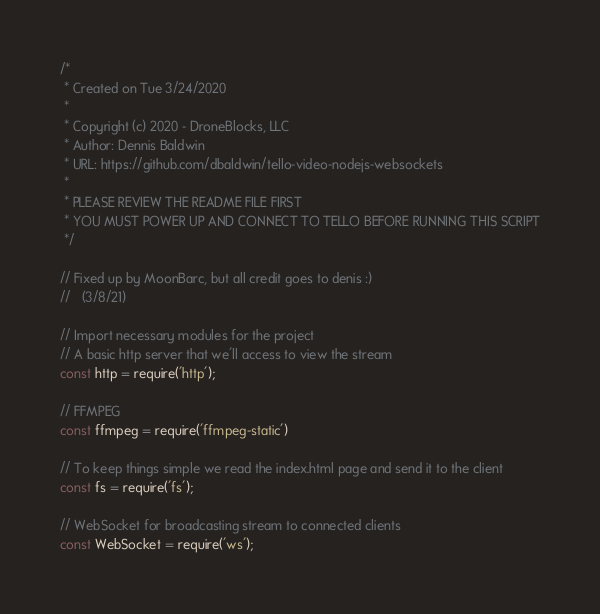<code> <loc_0><loc_0><loc_500><loc_500><_JavaScript_>/*
 * Created on Tue 3/24/2020
 *
 * Copyright (c) 2020 - DroneBlocks, LLC
 * Author: Dennis Baldwin
 * URL: https://github.com/dbaldwin/tello-video-nodejs-websockets
 *
 * PLEASE REVIEW THE README FILE FIRST
 * YOU MUST POWER UP AND CONNECT TO TELLO BEFORE RUNNING THIS SCRIPT
 */

// Fixed up by MoonBarc, but all credit goes to denis :)
//   (3/8/21)

// Import necessary modules for the project
// A basic http server that we'll access to view the stream
const http = require('http');

// FFMPEG
const ffmpeg = require('ffmpeg-static')

// To keep things simple we read the index.html page and send it to the client
const fs = require('fs');

// WebSocket for broadcasting stream to connected clients
const WebSocket = require('ws');
</code> 